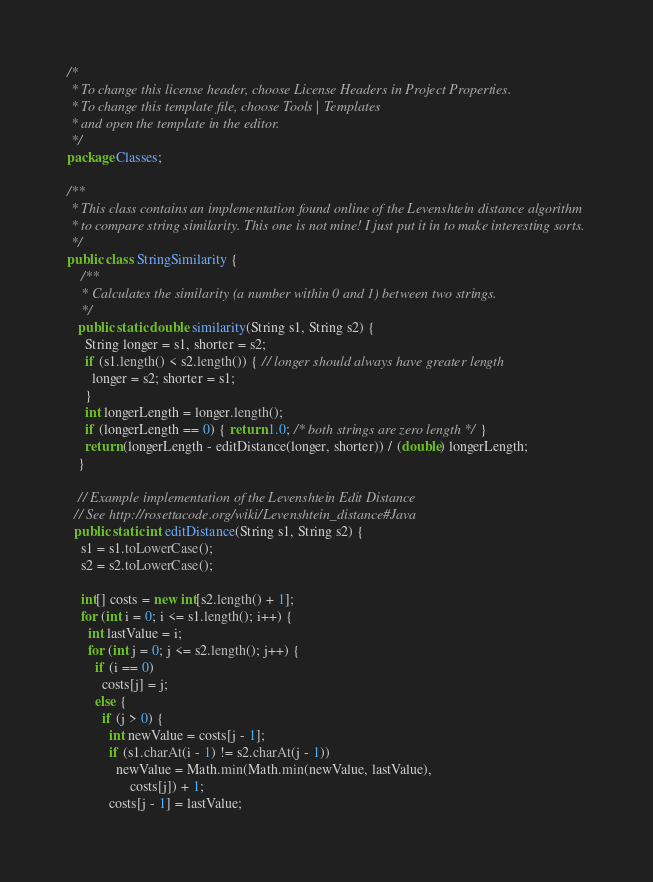<code> <loc_0><loc_0><loc_500><loc_500><_Java_>/*
 * To change this license header, choose License Headers in Project Properties.
 * To change this template file, choose Tools | Templates
 * and open the template in the editor.
 */
package Classes;

/**
 * This class contains an implementation found online of the Levenshtein distance algorithm 
 * to compare string similarity. This one is not mine! I just put it in to make interesting sorts.
 */
public class StringSimilarity {
    /**
    * Calculates the similarity (a number within 0 and 1) between two strings.
    */
   public static double similarity(String s1, String s2) {
     String longer = s1, shorter = s2;
     if (s1.length() < s2.length()) { // longer should always have greater length
       longer = s2; shorter = s1;
     }
     int longerLength = longer.length();
     if (longerLength == 0) { return 1.0; /* both strings are zero length */ }
     return (longerLength - editDistance(longer, shorter)) / (double) longerLength;
   }
   
   // Example implementation of the Levenshtein Edit Distance
  // See http://rosettacode.org/wiki/Levenshtein_distance#Java
  public static int editDistance(String s1, String s2) {
    s1 = s1.toLowerCase();
    s2 = s2.toLowerCase();

    int[] costs = new int[s2.length() + 1];
    for (int i = 0; i <= s1.length(); i++) {
      int lastValue = i;
      for (int j = 0; j <= s2.length(); j++) {
        if (i == 0)
          costs[j] = j;
        else {
          if (j > 0) {
            int newValue = costs[j - 1];
            if (s1.charAt(i - 1) != s2.charAt(j - 1))
              newValue = Math.min(Math.min(newValue, lastValue),
                  costs[j]) + 1;
            costs[j - 1] = lastValue;</code> 